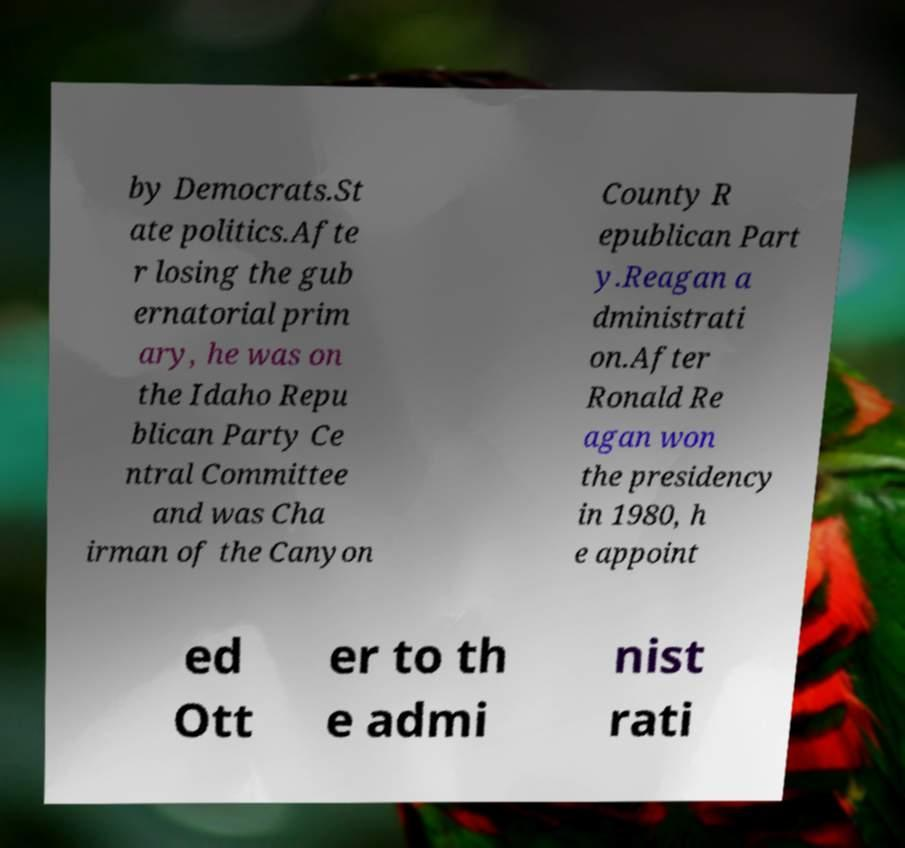I need the written content from this picture converted into text. Can you do that? by Democrats.St ate politics.Afte r losing the gub ernatorial prim ary, he was on the Idaho Repu blican Party Ce ntral Committee and was Cha irman of the Canyon County R epublican Part y.Reagan a dministrati on.After Ronald Re agan won the presidency in 1980, h e appoint ed Ott er to th e admi nist rati 